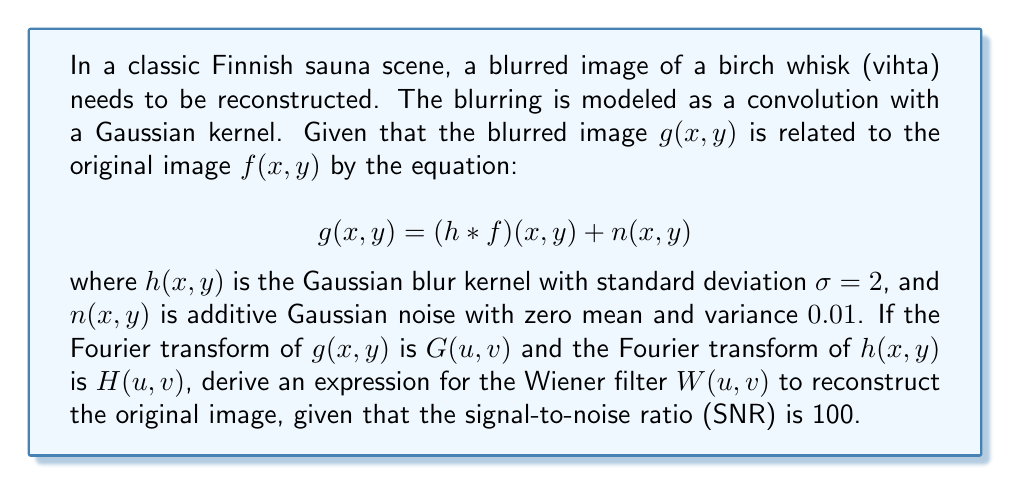Give your solution to this math problem. Let's approach this step-by-step:

1) The Wiener filter is designed to minimize the mean square error between the estimated image and the actual image. Its formula in the frequency domain is:

   $$W(u,v) = \frac{H^*(u,v)}{|H(u,v)|^2 + \frac{1}{SNR}}$$

   where $H^*(u,v)$ is the complex conjugate of $H(u,v)$.

2) We're given that the SNR is 100, so we can substitute this directly:

   $$W(u,v) = \frac{H^*(u,v)}{|H(u,v)|^2 + \frac{1}{100}}$$

3) Now, we need to determine $H(u,v)$. For a Gaussian blur kernel with standard deviation $\sigma$, the Fourier transform is also Gaussian:

   $$H(u,v) = e^{-\frac{u^2+v^2}{2\sigma^2}}$$

4) Substituting $\sigma = 2$:

   $$H(u,v) = e^{-\frac{u^2+v^2}{8}}$$

5) The complex conjugate $H^*(u,v)$ is the same as $H(u,v)$ in this case because the exponential is real:

   $$H^*(u,v) = e^{-\frac{u^2+v^2}{8}}$$

6) The magnitude squared $|H(u,v)|^2$ is:

   $$|H(u,v)|^2 = e^{-\frac{u^2+v^2}{4}}$$

7) Now we can substitute these into our Wiener filter equation:

   $$W(u,v) = \frac{e^{-\frac{u^2+v^2}{8}}}{e^{-\frac{u^2+v^2}{4}} + \frac{1}{100}}$$

This is the final expression for the Wiener filter to reconstruct the original image of the birch whisk.
Answer: $$W(u,v) = \frac{e^{-\frac{u^2+v^2}{8}}}{e^{-\frac{u^2+v^2}{4}} + \frac{1}{100}}$$ 